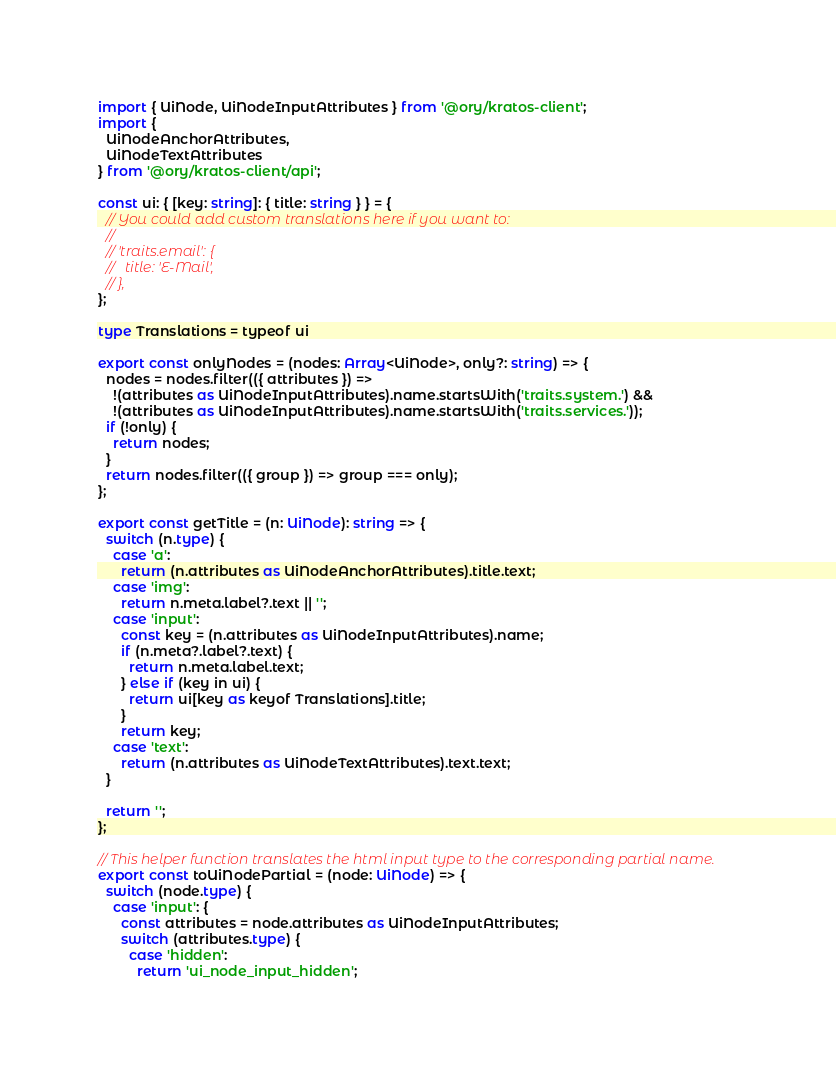<code> <loc_0><loc_0><loc_500><loc_500><_TypeScript_>import { UiNode, UiNodeInputAttributes } from '@ory/kratos-client';
import {
  UiNodeAnchorAttributes,
  UiNodeTextAttributes
} from '@ory/kratos-client/api';

const ui: { [key: string]: { title: string } } = {
  // You could add custom translations here if you want to:
  //
  // 'traits.email': {
  //   title: 'E-Mail',
  // },
};

type Translations = typeof ui

export const onlyNodes = (nodes: Array<UiNode>, only?: string) => {
  nodes = nodes.filter(({ attributes }) =>
    !(attributes as UiNodeInputAttributes).name.startsWith('traits.system.') &&
    !(attributes as UiNodeInputAttributes).name.startsWith('traits.services.'));
  if (!only) {
    return nodes;
  }
  return nodes.filter(({ group }) => group === only);
};

export const getTitle = (n: UiNode): string => {
  switch (n.type) {
    case 'a':
      return (n.attributes as UiNodeAnchorAttributes).title.text;
    case 'img':
      return n.meta.label?.text || '';
    case 'input':
      const key = (n.attributes as UiNodeInputAttributes).name;
      if (n.meta?.label?.text) {
        return n.meta.label.text;
      } else if (key in ui) {
        return ui[key as keyof Translations].title;
      }
      return key;
    case 'text':
      return (n.attributes as UiNodeTextAttributes).text.text;
  }

  return '';
};

// This helper function translates the html input type to the corresponding partial name.
export const toUiNodePartial = (node: UiNode) => {
  switch (node.type) {
    case 'input': {
      const attributes = node.attributes as UiNodeInputAttributes;
      switch (attributes.type) {
        case 'hidden':
          return 'ui_node_input_hidden';</code> 